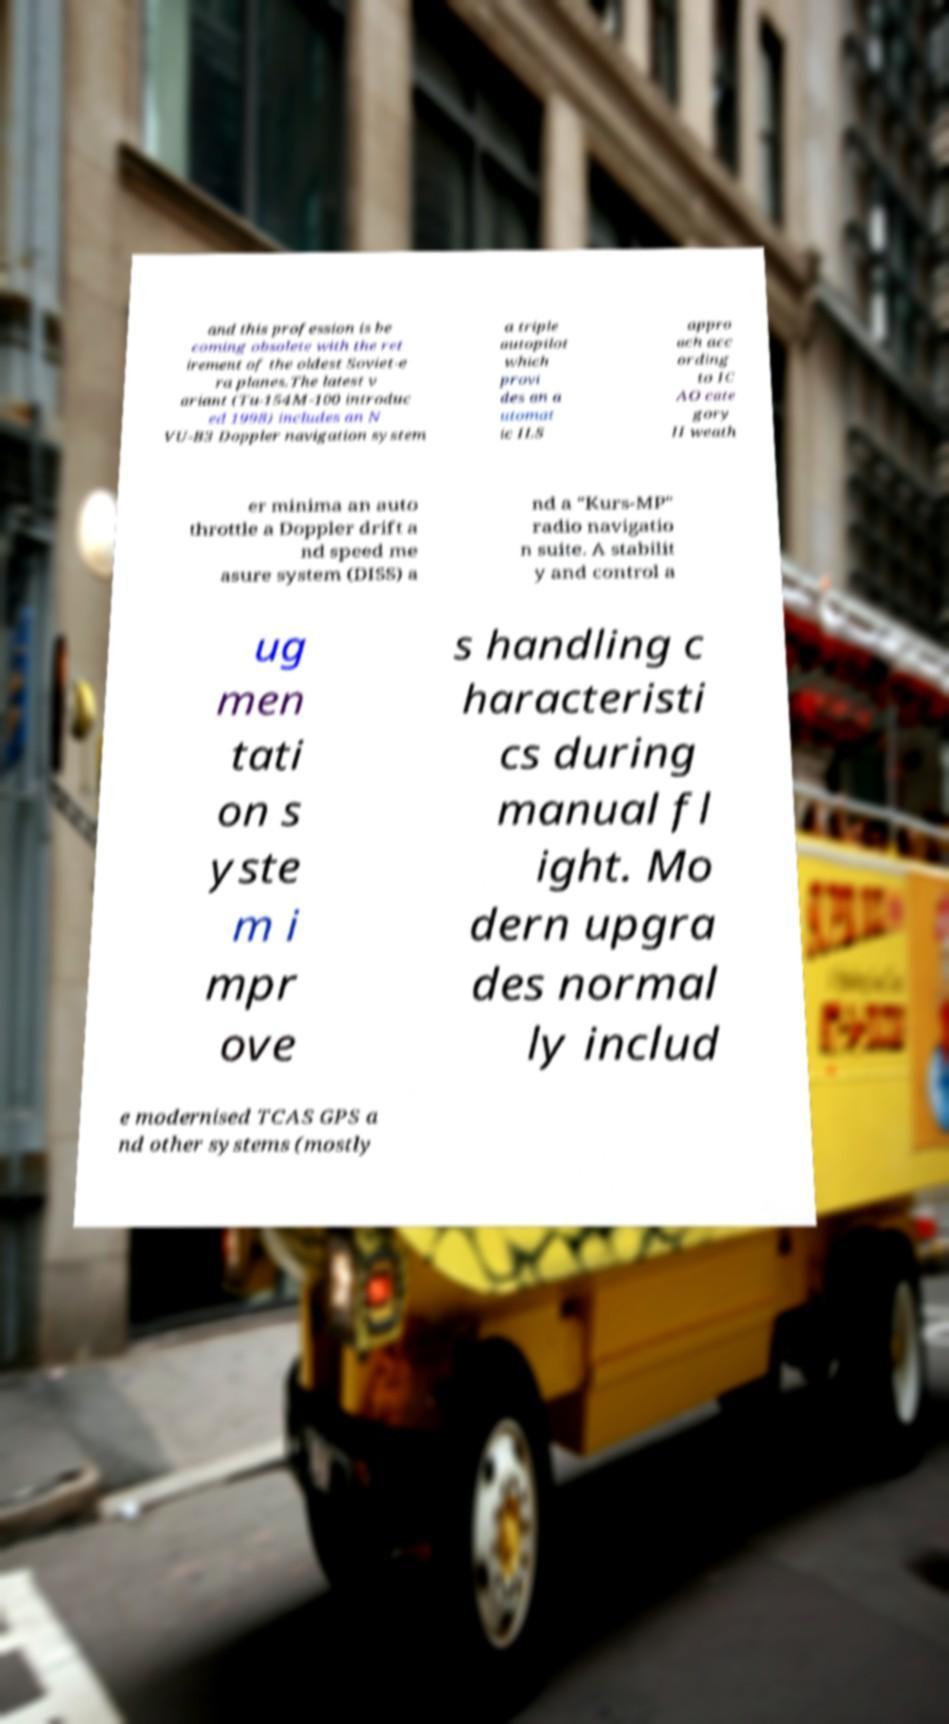Could you assist in decoding the text presented in this image and type it out clearly? and this profession is be coming obsolete with the ret irement of the oldest Soviet-e ra planes.The latest v ariant (Tu-154M-100 introduc ed 1998) includes an N VU-B3 Doppler navigation system a triple autopilot which provi des an a utomat ic ILS appro ach acc ording to IC AO cate gory II weath er minima an auto throttle a Doppler drift a nd speed me asure system (DISS) a nd a "Kurs-MP" radio navigatio n suite. A stabilit y and control a ug men tati on s yste m i mpr ove s handling c haracteristi cs during manual fl ight. Mo dern upgra des normal ly includ e modernised TCAS GPS a nd other systems (mostly 